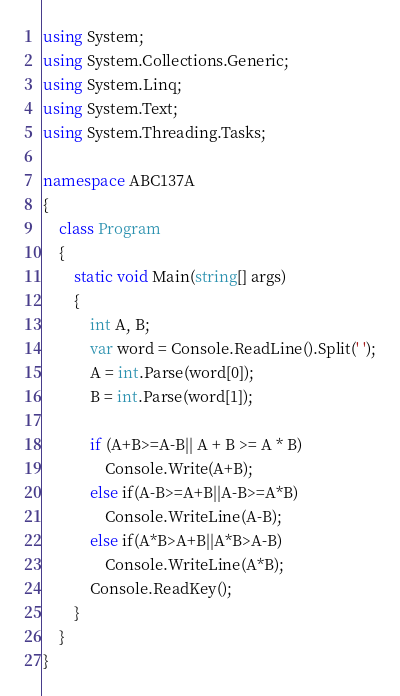<code> <loc_0><loc_0><loc_500><loc_500><_C#_>using System;
using System.Collections.Generic;
using System.Linq;
using System.Text;
using System.Threading.Tasks;

namespace ABC137A
{
	class Program
	{
		static void Main(string[] args)
		{
			int A, B;
			var word = Console.ReadLine().Split(' ');
			A = int.Parse(word[0]);
			B = int.Parse(word[1]);

			if (A+B>=A-B|| A + B >= A * B)
				Console.Write(A+B);
			else if(A-B>=A+B||A-B>=A*B)
				Console.WriteLine(A-B);
			else if(A*B>A+B||A*B>A-B)
				Console.WriteLine(A*B);
			Console.ReadKey();
		}
	}
}
</code> 